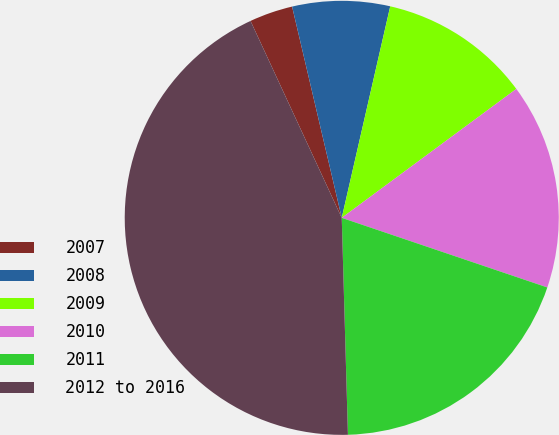Convert chart. <chart><loc_0><loc_0><loc_500><loc_500><pie_chart><fcel>2007<fcel>2008<fcel>2009<fcel>2010<fcel>2011<fcel>2012 to 2016<nl><fcel>3.23%<fcel>7.26%<fcel>11.29%<fcel>15.32%<fcel>19.35%<fcel>43.55%<nl></chart> 